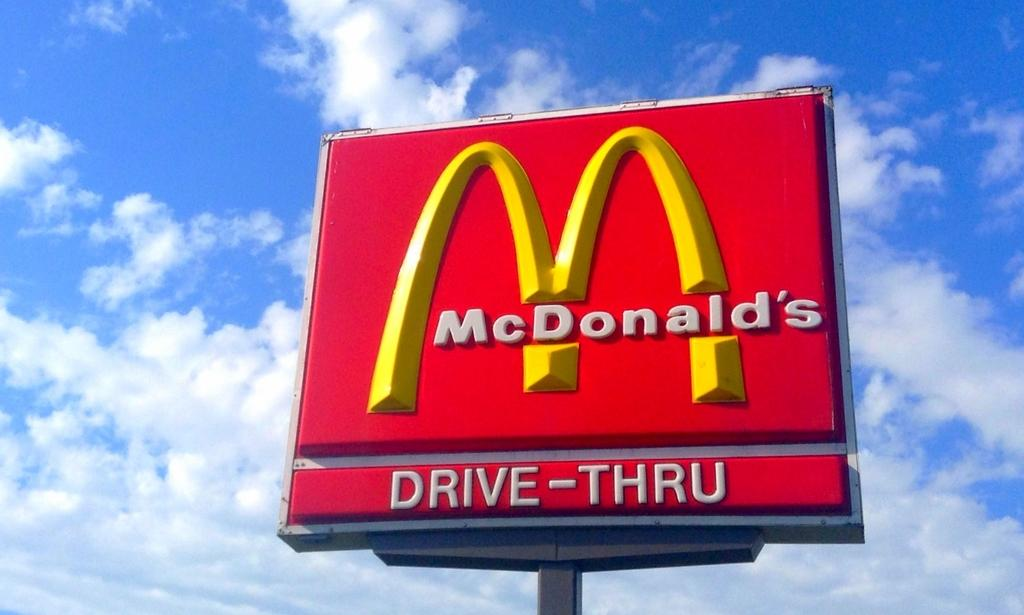<image>
Describe the image concisely. a billboard for mcdonalds drive-thru outside on a cloudy day 